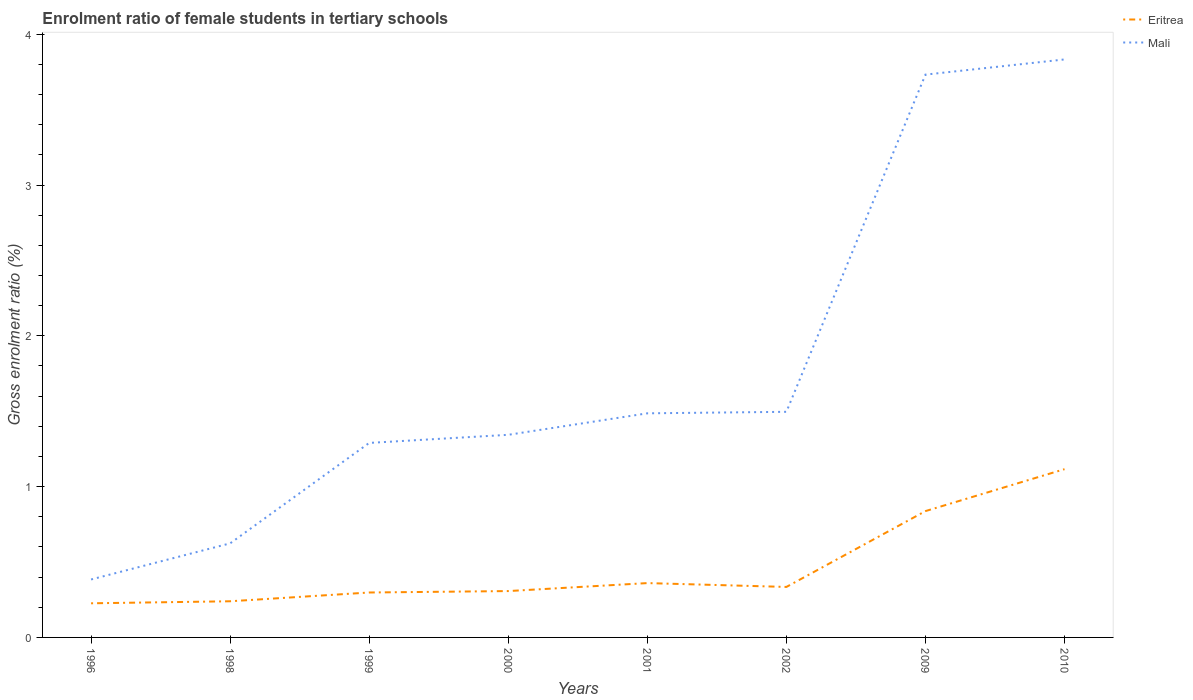Is the number of lines equal to the number of legend labels?
Provide a succinct answer. Yes. Across all years, what is the maximum enrolment ratio of female students in tertiary schools in Eritrea?
Provide a succinct answer. 0.23. In which year was the enrolment ratio of female students in tertiary schools in Mali maximum?
Keep it short and to the point. 1996. What is the total enrolment ratio of female students in tertiary schools in Eritrea in the graph?
Provide a succinct answer. -0.07. What is the difference between the highest and the second highest enrolment ratio of female students in tertiary schools in Mali?
Offer a very short reply. 3.45. How many lines are there?
Your answer should be very brief. 2. How many years are there in the graph?
Offer a very short reply. 8. What is the difference between two consecutive major ticks on the Y-axis?
Your answer should be compact. 1. Does the graph contain any zero values?
Your answer should be compact. No. Does the graph contain grids?
Provide a succinct answer. No. What is the title of the graph?
Ensure brevity in your answer.  Enrolment ratio of female students in tertiary schools. What is the label or title of the X-axis?
Provide a succinct answer. Years. What is the Gross enrolment ratio (%) in Eritrea in 1996?
Ensure brevity in your answer.  0.23. What is the Gross enrolment ratio (%) of Mali in 1996?
Your answer should be very brief. 0.38. What is the Gross enrolment ratio (%) in Eritrea in 1998?
Keep it short and to the point. 0.24. What is the Gross enrolment ratio (%) in Mali in 1998?
Keep it short and to the point. 0.62. What is the Gross enrolment ratio (%) of Eritrea in 1999?
Your answer should be very brief. 0.3. What is the Gross enrolment ratio (%) in Mali in 1999?
Give a very brief answer. 1.29. What is the Gross enrolment ratio (%) in Eritrea in 2000?
Offer a terse response. 0.31. What is the Gross enrolment ratio (%) in Mali in 2000?
Provide a succinct answer. 1.34. What is the Gross enrolment ratio (%) of Eritrea in 2001?
Provide a short and direct response. 0.36. What is the Gross enrolment ratio (%) of Mali in 2001?
Ensure brevity in your answer.  1.49. What is the Gross enrolment ratio (%) of Eritrea in 2002?
Your answer should be compact. 0.33. What is the Gross enrolment ratio (%) of Mali in 2002?
Your answer should be compact. 1.5. What is the Gross enrolment ratio (%) of Eritrea in 2009?
Your answer should be very brief. 0.84. What is the Gross enrolment ratio (%) of Mali in 2009?
Keep it short and to the point. 3.73. What is the Gross enrolment ratio (%) in Eritrea in 2010?
Make the answer very short. 1.12. What is the Gross enrolment ratio (%) in Mali in 2010?
Offer a very short reply. 3.83. Across all years, what is the maximum Gross enrolment ratio (%) in Eritrea?
Offer a terse response. 1.12. Across all years, what is the maximum Gross enrolment ratio (%) in Mali?
Ensure brevity in your answer.  3.83. Across all years, what is the minimum Gross enrolment ratio (%) of Eritrea?
Give a very brief answer. 0.23. Across all years, what is the minimum Gross enrolment ratio (%) in Mali?
Offer a very short reply. 0.38. What is the total Gross enrolment ratio (%) of Eritrea in the graph?
Ensure brevity in your answer.  3.72. What is the total Gross enrolment ratio (%) of Mali in the graph?
Offer a terse response. 14.19. What is the difference between the Gross enrolment ratio (%) in Eritrea in 1996 and that in 1998?
Your answer should be very brief. -0.01. What is the difference between the Gross enrolment ratio (%) in Mali in 1996 and that in 1998?
Offer a terse response. -0.24. What is the difference between the Gross enrolment ratio (%) of Eritrea in 1996 and that in 1999?
Offer a very short reply. -0.07. What is the difference between the Gross enrolment ratio (%) in Mali in 1996 and that in 1999?
Offer a terse response. -0.91. What is the difference between the Gross enrolment ratio (%) of Eritrea in 1996 and that in 2000?
Keep it short and to the point. -0.08. What is the difference between the Gross enrolment ratio (%) in Mali in 1996 and that in 2000?
Your answer should be compact. -0.96. What is the difference between the Gross enrolment ratio (%) in Eritrea in 1996 and that in 2001?
Your answer should be compact. -0.13. What is the difference between the Gross enrolment ratio (%) of Mali in 1996 and that in 2001?
Provide a succinct answer. -1.1. What is the difference between the Gross enrolment ratio (%) in Eritrea in 1996 and that in 2002?
Your answer should be very brief. -0.11. What is the difference between the Gross enrolment ratio (%) in Mali in 1996 and that in 2002?
Your answer should be very brief. -1.11. What is the difference between the Gross enrolment ratio (%) in Eritrea in 1996 and that in 2009?
Your answer should be very brief. -0.61. What is the difference between the Gross enrolment ratio (%) in Mali in 1996 and that in 2009?
Give a very brief answer. -3.35. What is the difference between the Gross enrolment ratio (%) of Eritrea in 1996 and that in 2010?
Your answer should be very brief. -0.89. What is the difference between the Gross enrolment ratio (%) in Mali in 1996 and that in 2010?
Give a very brief answer. -3.45. What is the difference between the Gross enrolment ratio (%) of Eritrea in 1998 and that in 1999?
Give a very brief answer. -0.06. What is the difference between the Gross enrolment ratio (%) in Mali in 1998 and that in 1999?
Keep it short and to the point. -0.67. What is the difference between the Gross enrolment ratio (%) in Eritrea in 1998 and that in 2000?
Provide a succinct answer. -0.07. What is the difference between the Gross enrolment ratio (%) in Mali in 1998 and that in 2000?
Offer a terse response. -0.72. What is the difference between the Gross enrolment ratio (%) in Eritrea in 1998 and that in 2001?
Your answer should be very brief. -0.12. What is the difference between the Gross enrolment ratio (%) in Mali in 1998 and that in 2001?
Provide a succinct answer. -0.86. What is the difference between the Gross enrolment ratio (%) in Eritrea in 1998 and that in 2002?
Provide a succinct answer. -0.1. What is the difference between the Gross enrolment ratio (%) of Mali in 1998 and that in 2002?
Provide a short and direct response. -0.87. What is the difference between the Gross enrolment ratio (%) of Eritrea in 1998 and that in 2009?
Offer a terse response. -0.6. What is the difference between the Gross enrolment ratio (%) in Mali in 1998 and that in 2009?
Provide a succinct answer. -3.11. What is the difference between the Gross enrolment ratio (%) of Eritrea in 1998 and that in 2010?
Give a very brief answer. -0.88. What is the difference between the Gross enrolment ratio (%) of Mali in 1998 and that in 2010?
Provide a short and direct response. -3.21. What is the difference between the Gross enrolment ratio (%) of Eritrea in 1999 and that in 2000?
Give a very brief answer. -0.01. What is the difference between the Gross enrolment ratio (%) of Mali in 1999 and that in 2000?
Make the answer very short. -0.05. What is the difference between the Gross enrolment ratio (%) of Eritrea in 1999 and that in 2001?
Make the answer very short. -0.06. What is the difference between the Gross enrolment ratio (%) in Mali in 1999 and that in 2001?
Your response must be concise. -0.2. What is the difference between the Gross enrolment ratio (%) in Eritrea in 1999 and that in 2002?
Make the answer very short. -0.04. What is the difference between the Gross enrolment ratio (%) of Mali in 1999 and that in 2002?
Make the answer very short. -0.21. What is the difference between the Gross enrolment ratio (%) of Eritrea in 1999 and that in 2009?
Offer a very short reply. -0.54. What is the difference between the Gross enrolment ratio (%) of Mali in 1999 and that in 2009?
Make the answer very short. -2.44. What is the difference between the Gross enrolment ratio (%) of Eritrea in 1999 and that in 2010?
Your response must be concise. -0.82. What is the difference between the Gross enrolment ratio (%) of Mali in 1999 and that in 2010?
Provide a short and direct response. -2.54. What is the difference between the Gross enrolment ratio (%) of Eritrea in 2000 and that in 2001?
Offer a very short reply. -0.05. What is the difference between the Gross enrolment ratio (%) in Mali in 2000 and that in 2001?
Your answer should be compact. -0.14. What is the difference between the Gross enrolment ratio (%) in Eritrea in 2000 and that in 2002?
Your answer should be very brief. -0.03. What is the difference between the Gross enrolment ratio (%) in Mali in 2000 and that in 2002?
Give a very brief answer. -0.15. What is the difference between the Gross enrolment ratio (%) of Eritrea in 2000 and that in 2009?
Your answer should be compact. -0.53. What is the difference between the Gross enrolment ratio (%) in Mali in 2000 and that in 2009?
Your response must be concise. -2.39. What is the difference between the Gross enrolment ratio (%) in Eritrea in 2000 and that in 2010?
Offer a very short reply. -0.81. What is the difference between the Gross enrolment ratio (%) of Mali in 2000 and that in 2010?
Make the answer very short. -2.49. What is the difference between the Gross enrolment ratio (%) of Eritrea in 2001 and that in 2002?
Offer a terse response. 0.03. What is the difference between the Gross enrolment ratio (%) of Mali in 2001 and that in 2002?
Give a very brief answer. -0.01. What is the difference between the Gross enrolment ratio (%) of Eritrea in 2001 and that in 2009?
Your answer should be compact. -0.48. What is the difference between the Gross enrolment ratio (%) in Mali in 2001 and that in 2009?
Your answer should be very brief. -2.25. What is the difference between the Gross enrolment ratio (%) of Eritrea in 2001 and that in 2010?
Ensure brevity in your answer.  -0.76. What is the difference between the Gross enrolment ratio (%) of Mali in 2001 and that in 2010?
Your answer should be very brief. -2.35. What is the difference between the Gross enrolment ratio (%) in Eritrea in 2002 and that in 2009?
Your answer should be very brief. -0.5. What is the difference between the Gross enrolment ratio (%) in Mali in 2002 and that in 2009?
Provide a short and direct response. -2.24. What is the difference between the Gross enrolment ratio (%) of Eritrea in 2002 and that in 2010?
Keep it short and to the point. -0.78. What is the difference between the Gross enrolment ratio (%) of Mali in 2002 and that in 2010?
Keep it short and to the point. -2.34. What is the difference between the Gross enrolment ratio (%) of Eritrea in 2009 and that in 2010?
Your answer should be very brief. -0.28. What is the difference between the Gross enrolment ratio (%) of Mali in 2009 and that in 2010?
Offer a terse response. -0.1. What is the difference between the Gross enrolment ratio (%) in Eritrea in 1996 and the Gross enrolment ratio (%) in Mali in 1998?
Your answer should be very brief. -0.4. What is the difference between the Gross enrolment ratio (%) in Eritrea in 1996 and the Gross enrolment ratio (%) in Mali in 1999?
Your answer should be compact. -1.06. What is the difference between the Gross enrolment ratio (%) in Eritrea in 1996 and the Gross enrolment ratio (%) in Mali in 2000?
Your answer should be compact. -1.12. What is the difference between the Gross enrolment ratio (%) in Eritrea in 1996 and the Gross enrolment ratio (%) in Mali in 2001?
Offer a terse response. -1.26. What is the difference between the Gross enrolment ratio (%) of Eritrea in 1996 and the Gross enrolment ratio (%) of Mali in 2002?
Your answer should be compact. -1.27. What is the difference between the Gross enrolment ratio (%) of Eritrea in 1996 and the Gross enrolment ratio (%) of Mali in 2009?
Provide a short and direct response. -3.51. What is the difference between the Gross enrolment ratio (%) in Eritrea in 1996 and the Gross enrolment ratio (%) in Mali in 2010?
Offer a very short reply. -3.61. What is the difference between the Gross enrolment ratio (%) in Eritrea in 1998 and the Gross enrolment ratio (%) in Mali in 1999?
Keep it short and to the point. -1.05. What is the difference between the Gross enrolment ratio (%) of Eritrea in 1998 and the Gross enrolment ratio (%) of Mali in 2000?
Offer a very short reply. -1.1. What is the difference between the Gross enrolment ratio (%) in Eritrea in 1998 and the Gross enrolment ratio (%) in Mali in 2001?
Ensure brevity in your answer.  -1.25. What is the difference between the Gross enrolment ratio (%) in Eritrea in 1998 and the Gross enrolment ratio (%) in Mali in 2002?
Provide a short and direct response. -1.26. What is the difference between the Gross enrolment ratio (%) in Eritrea in 1998 and the Gross enrolment ratio (%) in Mali in 2009?
Provide a short and direct response. -3.49. What is the difference between the Gross enrolment ratio (%) in Eritrea in 1998 and the Gross enrolment ratio (%) in Mali in 2010?
Keep it short and to the point. -3.59. What is the difference between the Gross enrolment ratio (%) of Eritrea in 1999 and the Gross enrolment ratio (%) of Mali in 2000?
Provide a short and direct response. -1.05. What is the difference between the Gross enrolment ratio (%) of Eritrea in 1999 and the Gross enrolment ratio (%) of Mali in 2001?
Offer a terse response. -1.19. What is the difference between the Gross enrolment ratio (%) in Eritrea in 1999 and the Gross enrolment ratio (%) in Mali in 2002?
Offer a very short reply. -1.2. What is the difference between the Gross enrolment ratio (%) in Eritrea in 1999 and the Gross enrolment ratio (%) in Mali in 2009?
Your answer should be compact. -3.43. What is the difference between the Gross enrolment ratio (%) of Eritrea in 1999 and the Gross enrolment ratio (%) of Mali in 2010?
Provide a short and direct response. -3.53. What is the difference between the Gross enrolment ratio (%) of Eritrea in 2000 and the Gross enrolment ratio (%) of Mali in 2001?
Ensure brevity in your answer.  -1.18. What is the difference between the Gross enrolment ratio (%) in Eritrea in 2000 and the Gross enrolment ratio (%) in Mali in 2002?
Keep it short and to the point. -1.19. What is the difference between the Gross enrolment ratio (%) in Eritrea in 2000 and the Gross enrolment ratio (%) in Mali in 2009?
Your answer should be very brief. -3.42. What is the difference between the Gross enrolment ratio (%) of Eritrea in 2000 and the Gross enrolment ratio (%) of Mali in 2010?
Provide a short and direct response. -3.53. What is the difference between the Gross enrolment ratio (%) of Eritrea in 2001 and the Gross enrolment ratio (%) of Mali in 2002?
Offer a very short reply. -1.14. What is the difference between the Gross enrolment ratio (%) of Eritrea in 2001 and the Gross enrolment ratio (%) of Mali in 2009?
Keep it short and to the point. -3.37. What is the difference between the Gross enrolment ratio (%) of Eritrea in 2001 and the Gross enrolment ratio (%) of Mali in 2010?
Provide a short and direct response. -3.47. What is the difference between the Gross enrolment ratio (%) of Eritrea in 2002 and the Gross enrolment ratio (%) of Mali in 2009?
Offer a terse response. -3.4. What is the difference between the Gross enrolment ratio (%) of Eritrea in 2002 and the Gross enrolment ratio (%) of Mali in 2010?
Make the answer very short. -3.5. What is the difference between the Gross enrolment ratio (%) in Eritrea in 2009 and the Gross enrolment ratio (%) in Mali in 2010?
Ensure brevity in your answer.  -2.99. What is the average Gross enrolment ratio (%) in Eritrea per year?
Your answer should be compact. 0.47. What is the average Gross enrolment ratio (%) of Mali per year?
Offer a very short reply. 1.77. In the year 1996, what is the difference between the Gross enrolment ratio (%) in Eritrea and Gross enrolment ratio (%) in Mali?
Give a very brief answer. -0.16. In the year 1998, what is the difference between the Gross enrolment ratio (%) of Eritrea and Gross enrolment ratio (%) of Mali?
Give a very brief answer. -0.38. In the year 1999, what is the difference between the Gross enrolment ratio (%) in Eritrea and Gross enrolment ratio (%) in Mali?
Your answer should be very brief. -0.99. In the year 2000, what is the difference between the Gross enrolment ratio (%) of Eritrea and Gross enrolment ratio (%) of Mali?
Offer a terse response. -1.04. In the year 2001, what is the difference between the Gross enrolment ratio (%) of Eritrea and Gross enrolment ratio (%) of Mali?
Your answer should be very brief. -1.13. In the year 2002, what is the difference between the Gross enrolment ratio (%) of Eritrea and Gross enrolment ratio (%) of Mali?
Ensure brevity in your answer.  -1.16. In the year 2009, what is the difference between the Gross enrolment ratio (%) of Eritrea and Gross enrolment ratio (%) of Mali?
Your response must be concise. -2.89. In the year 2010, what is the difference between the Gross enrolment ratio (%) of Eritrea and Gross enrolment ratio (%) of Mali?
Your response must be concise. -2.72. What is the ratio of the Gross enrolment ratio (%) of Eritrea in 1996 to that in 1998?
Provide a succinct answer. 0.94. What is the ratio of the Gross enrolment ratio (%) in Mali in 1996 to that in 1998?
Keep it short and to the point. 0.62. What is the ratio of the Gross enrolment ratio (%) of Eritrea in 1996 to that in 1999?
Make the answer very short. 0.76. What is the ratio of the Gross enrolment ratio (%) in Mali in 1996 to that in 1999?
Your answer should be compact. 0.3. What is the ratio of the Gross enrolment ratio (%) in Eritrea in 1996 to that in 2000?
Make the answer very short. 0.74. What is the ratio of the Gross enrolment ratio (%) in Mali in 1996 to that in 2000?
Your response must be concise. 0.29. What is the ratio of the Gross enrolment ratio (%) of Eritrea in 1996 to that in 2001?
Provide a short and direct response. 0.63. What is the ratio of the Gross enrolment ratio (%) in Mali in 1996 to that in 2001?
Make the answer very short. 0.26. What is the ratio of the Gross enrolment ratio (%) of Eritrea in 1996 to that in 2002?
Your answer should be very brief. 0.68. What is the ratio of the Gross enrolment ratio (%) in Mali in 1996 to that in 2002?
Your answer should be very brief. 0.26. What is the ratio of the Gross enrolment ratio (%) of Eritrea in 1996 to that in 2009?
Your answer should be compact. 0.27. What is the ratio of the Gross enrolment ratio (%) in Mali in 1996 to that in 2009?
Your answer should be very brief. 0.1. What is the ratio of the Gross enrolment ratio (%) of Eritrea in 1996 to that in 2010?
Your answer should be very brief. 0.2. What is the ratio of the Gross enrolment ratio (%) of Mali in 1996 to that in 2010?
Your answer should be very brief. 0.1. What is the ratio of the Gross enrolment ratio (%) of Eritrea in 1998 to that in 1999?
Ensure brevity in your answer.  0.8. What is the ratio of the Gross enrolment ratio (%) of Mali in 1998 to that in 1999?
Give a very brief answer. 0.48. What is the ratio of the Gross enrolment ratio (%) in Eritrea in 1998 to that in 2000?
Make the answer very short. 0.78. What is the ratio of the Gross enrolment ratio (%) in Mali in 1998 to that in 2000?
Offer a terse response. 0.46. What is the ratio of the Gross enrolment ratio (%) in Eritrea in 1998 to that in 2001?
Make the answer very short. 0.67. What is the ratio of the Gross enrolment ratio (%) in Mali in 1998 to that in 2001?
Provide a succinct answer. 0.42. What is the ratio of the Gross enrolment ratio (%) of Eritrea in 1998 to that in 2002?
Keep it short and to the point. 0.72. What is the ratio of the Gross enrolment ratio (%) of Mali in 1998 to that in 2002?
Give a very brief answer. 0.42. What is the ratio of the Gross enrolment ratio (%) of Eritrea in 1998 to that in 2009?
Your response must be concise. 0.29. What is the ratio of the Gross enrolment ratio (%) in Mali in 1998 to that in 2009?
Your answer should be compact. 0.17. What is the ratio of the Gross enrolment ratio (%) in Eritrea in 1998 to that in 2010?
Offer a very short reply. 0.21. What is the ratio of the Gross enrolment ratio (%) of Mali in 1998 to that in 2010?
Provide a short and direct response. 0.16. What is the ratio of the Gross enrolment ratio (%) of Eritrea in 1999 to that in 2000?
Provide a succinct answer. 0.97. What is the ratio of the Gross enrolment ratio (%) of Eritrea in 1999 to that in 2001?
Your answer should be compact. 0.83. What is the ratio of the Gross enrolment ratio (%) of Mali in 1999 to that in 2001?
Provide a short and direct response. 0.87. What is the ratio of the Gross enrolment ratio (%) of Eritrea in 1999 to that in 2002?
Ensure brevity in your answer.  0.89. What is the ratio of the Gross enrolment ratio (%) in Mali in 1999 to that in 2002?
Make the answer very short. 0.86. What is the ratio of the Gross enrolment ratio (%) in Eritrea in 1999 to that in 2009?
Provide a short and direct response. 0.36. What is the ratio of the Gross enrolment ratio (%) in Mali in 1999 to that in 2009?
Give a very brief answer. 0.35. What is the ratio of the Gross enrolment ratio (%) in Eritrea in 1999 to that in 2010?
Ensure brevity in your answer.  0.27. What is the ratio of the Gross enrolment ratio (%) of Mali in 1999 to that in 2010?
Your answer should be very brief. 0.34. What is the ratio of the Gross enrolment ratio (%) in Eritrea in 2000 to that in 2001?
Your answer should be very brief. 0.85. What is the ratio of the Gross enrolment ratio (%) in Mali in 2000 to that in 2001?
Your answer should be very brief. 0.9. What is the ratio of the Gross enrolment ratio (%) in Eritrea in 2000 to that in 2002?
Make the answer very short. 0.92. What is the ratio of the Gross enrolment ratio (%) in Mali in 2000 to that in 2002?
Keep it short and to the point. 0.9. What is the ratio of the Gross enrolment ratio (%) of Eritrea in 2000 to that in 2009?
Keep it short and to the point. 0.37. What is the ratio of the Gross enrolment ratio (%) of Mali in 2000 to that in 2009?
Offer a terse response. 0.36. What is the ratio of the Gross enrolment ratio (%) of Eritrea in 2000 to that in 2010?
Make the answer very short. 0.28. What is the ratio of the Gross enrolment ratio (%) of Mali in 2000 to that in 2010?
Your answer should be compact. 0.35. What is the ratio of the Gross enrolment ratio (%) of Eritrea in 2001 to that in 2002?
Offer a terse response. 1.08. What is the ratio of the Gross enrolment ratio (%) in Eritrea in 2001 to that in 2009?
Provide a succinct answer. 0.43. What is the ratio of the Gross enrolment ratio (%) of Mali in 2001 to that in 2009?
Your response must be concise. 0.4. What is the ratio of the Gross enrolment ratio (%) of Eritrea in 2001 to that in 2010?
Keep it short and to the point. 0.32. What is the ratio of the Gross enrolment ratio (%) of Mali in 2001 to that in 2010?
Provide a succinct answer. 0.39. What is the ratio of the Gross enrolment ratio (%) in Eritrea in 2002 to that in 2009?
Ensure brevity in your answer.  0.4. What is the ratio of the Gross enrolment ratio (%) in Mali in 2002 to that in 2009?
Provide a succinct answer. 0.4. What is the ratio of the Gross enrolment ratio (%) of Eritrea in 2002 to that in 2010?
Keep it short and to the point. 0.3. What is the ratio of the Gross enrolment ratio (%) of Mali in 2002 to that in 2010?
Ensure brevity in your answer.  0.39. What is the ratio of the Gross enrolment ratio (%) in Eritrea in 2009 to that in 2010?
Offer a terse response. 0.75. What is the ratio of the Gross enrolment ratio (%) of Mali in 2009 to that in 2010?
Offer a very short reply. 0.97. What is the difference between the highest and the second highest Gross enrolment ratio (%) in Eritrea?
Give a very brief answer. 0.28. What is the difference between the highest and the second highest Gross enrolment ratio (%) of Mali?
Your answer should be very brief. 0.1. What is the difference between the highest and the lowest Gross enrolment ratio (%) in Eritrea?
Offer a very short reply. 0.89. What is the difference between the highest and the lowest Gross enrolment ratio (%) of Mali?
Provide a short and direct response. 3.45. 